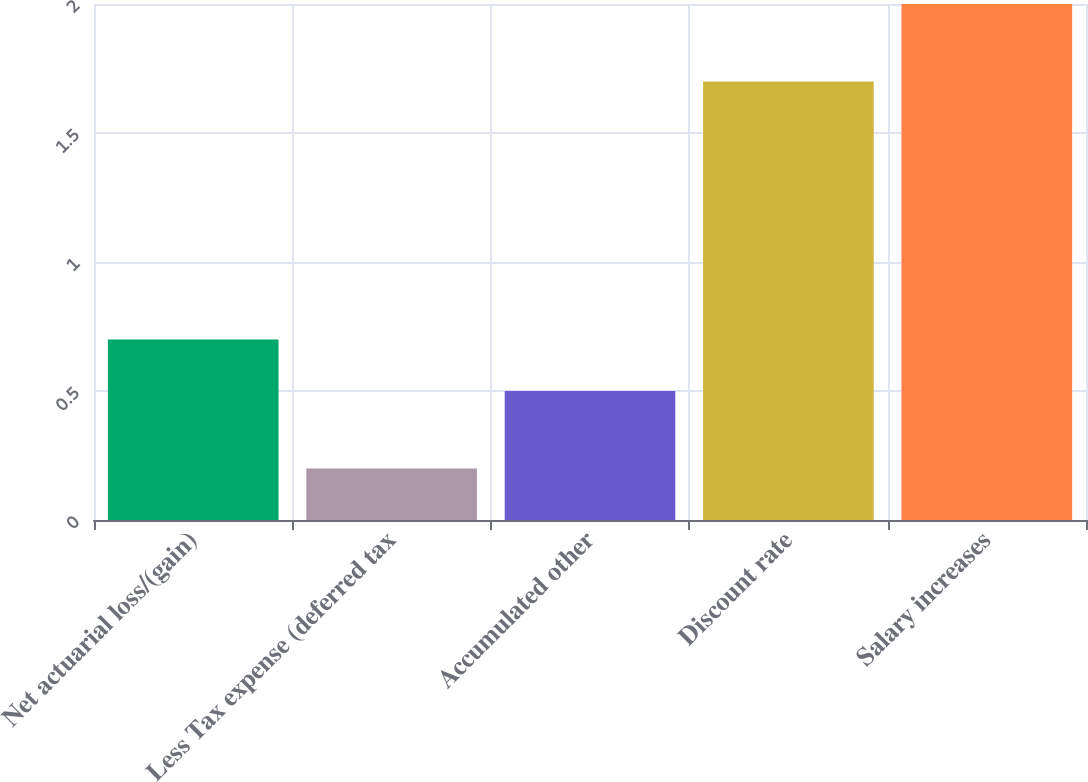Convert chart. <chart><loc_0><loc_0><loc_500><loc_500><bar_chart><fcel>Net actuarial loss/(gain)<fcel>Less Tax expense (deferred tax<fcel>Accumulated other<fcel>Discount rate<fcel>Salary increases<nl><fcel>0.7<fcel>0.2<fcel>0.5<fcel>1.7<fcel>2<nl></chart> 